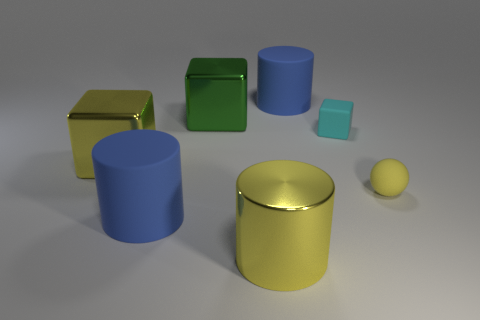Add 3 balls. How many objects exist? 10 Subtract all cylinders. How many objects are left? 4 Subtract all tiny yellow things. Subtract all cyan matte cubes. How many objects are left? 5 Add 4 yellow metal cubes. How many yellow metal cubes are left? 5 Add 7 tiny cubes. How many tiny cubes exist? 8 Subtract 0 purple spheres. How many objects are left? 7 